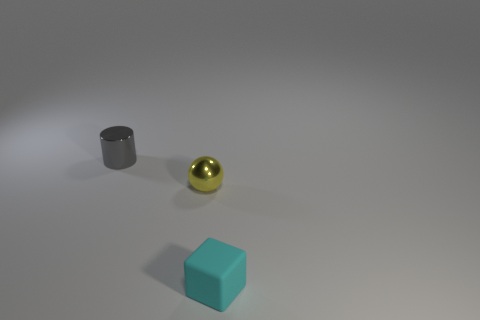There is a gray cylinder behind the shiny object that is in front of the metal thing that is behind the yellow thing; how big is it?
Provide a succinct answer. Small. What number of objects are either objects right of the cylinder or big red shiny spheres?
Ensure brevity in your answer.  2. There is a thing behind the yellow metallic thing; what number of small yellow things are to the left of it?
Offer a terse response. 0. Are there more small cyan rubber things that are right of the small matte block than tiny gray shiny cylinders?
Give a very brief answer. No. What size is the object that is behind the cyan object and in front of the metallic cylinder?
Offer a very short reply. Small. The tiny object that is both in front of the gray object and behind the cube has what shape?
Provide a short and direct response. Sphere. There is a shiny thing right of the metal object that is left of the small sphere; is there a metallic sphere that is to the left of it?
Ensure brevity in your answer.  No. What number of objects are small things that are to the left of the small cyan matte cube or tiny cyan rubber cubes in front of the yellow metallic ball?
Provide a short and direct response. 3. Do the tiny thing that is on the left side of the yellow ball and the small cyan cube have the same material?
Offer a terse response. No. What is the material of the thing that is behind the cyan thing and right of the small gray object?
Your answer should be compact. Metal. 